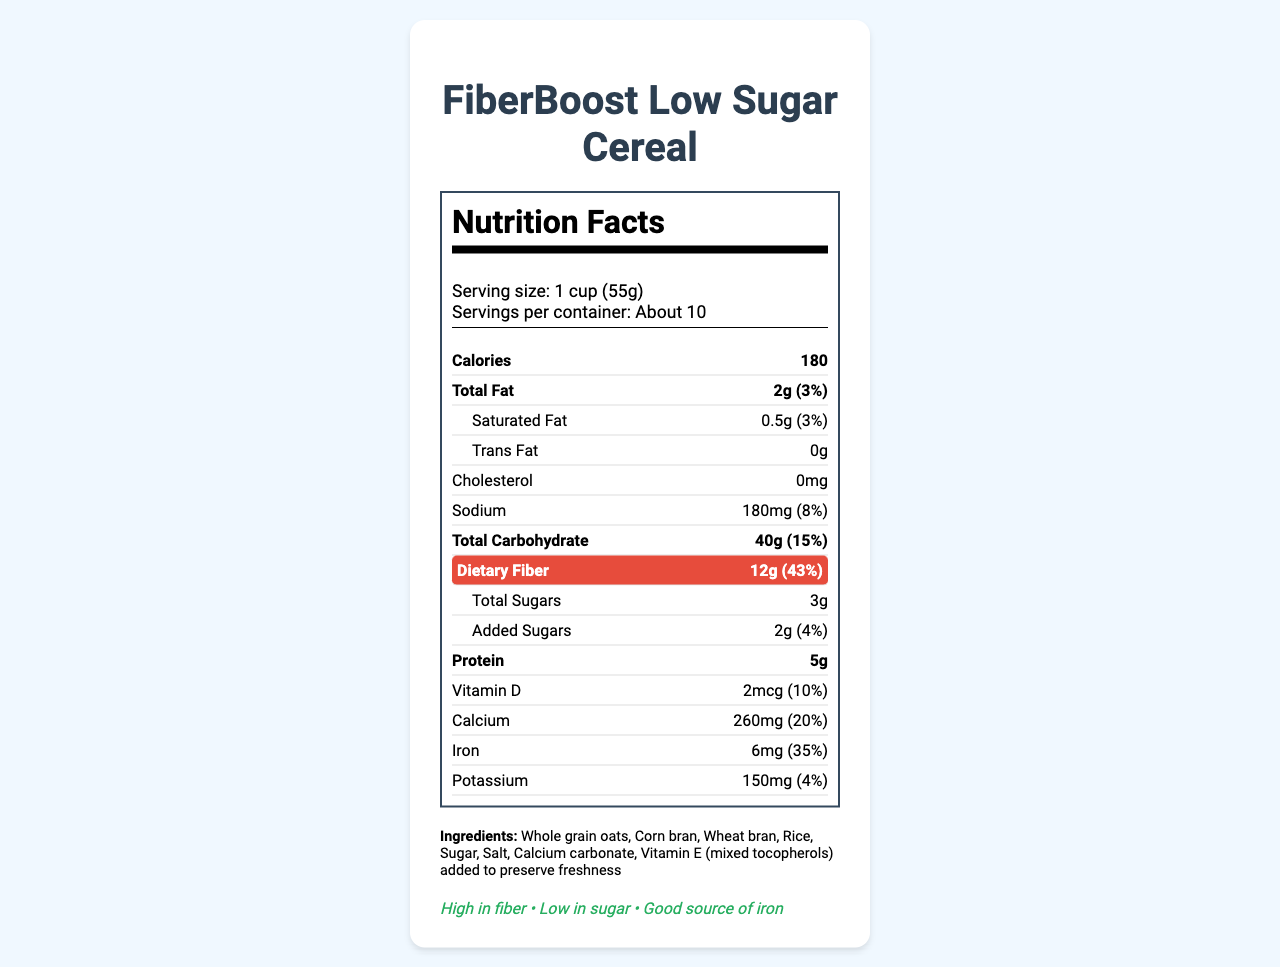What is the serving size for FiberBoost Low Sugar Cereal? The serving size is clearly mentioned under the Nutrition Facts section of the document.
Answer: 1 cup (55g) How many calories are in one serving of this cereal? The number of calories is indicated prominently in the Nutrition Facts section.
Answer: 180 What percentage of your daily fiber needs is met by one serving of this cereal? The dietary fiber information shows 12g, which is 43% of the daily value.
Answer: 43% List three key ingredients in this cereal. The Ingredients list includes whole grain oats, corn bran, and wheat bran among others.
Answer: Whole grain oats, Corn bran, Wheat bran What is the daily value percentage for calcium? The Nutrition Facts shows calcium content as 260mg, which is 20% of the daily value.
Answer: 20% How many grams of total sugars are in one serving? The total sugars amount is explicitly stated as 3g in the Nutrition Facts section.
Answer: 3g Which of the following health claims is NOT made by the product? A. High in fiber B. Low in sugar C. Gluten-free D. Good source of iron The health claims listed are "High in fiber", "Low in sugar", and "Good source of iron". "Gluten-free" is not mentioned.
Answer: C. Gluten-free What is the iron content per serving as a percentage of daily value? A. 10% B. 20% C. 35% D. 43% The iron daily value percentage is shown as 35% in the Nutrition Facts section.
Answer: C. 35% Is there any trans fat in FiberBoost Low Sugar Cereal? The document shows "0g" next to Trans Fat, which means the product contains no trans fat.
Answer: No Summarize the main nutritional highlights and health claims of FiberBoost Low Sugar Cereal. The summary covers the main nutritional aspects of high fiber and low sugar, the high iron content, whole grain ingredients, and the target audience, reflecting the key points visible in the document.
Answer: FiberBoost Low Sugar Cereal is a high-fiber, low-sugar breakfast option that provides significant amounts of iron and calcium. The cereal is made from whole grains and meets 43% of daily fiber needs, has only 3g of total sugars per serving, and is a good source of iron. It is targeted towards health-conscious adults aged 25-55. What is the key target audience for this cereal? The document specifies that the product is aimed at health-conscious adults aged 25-55.
Answer: Health-conscious adults aged 25-55 How many servings are in a container? The document lists "About 10" for servings per container in the Nutrition Facts section.
Answer: About 10 What ingredient is added to preserve freshness? The ingredients list mentions that Vitamin E (mixed tocopherols) is added to preserve freshness.
Answer: Vitamin E (mixed tocopherols) Which mineral is present in the highest amount by daily value percentage? Iron's daily value percentage is 35%, which is higher than the other minerals listed.
Answer: Iron What health benefits do you associate with high-fiber cereals? The document does not provide specific health benefits associated with high-fiber cereals, rather it lists fiber content and some health claims.
Answer: Not enough information Do you think that online surveys are effective data collection methods for consumer insights on breakfast cereals? The effectiveness of online surveys is not directly discussed or illustrated within the document.
Answer: Cannot be determined 